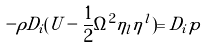Convert formula to latex. <formula><loc_0><loc_0><loc_500><loc_500>- \rho D _ { i } ( U - \frac { 1 } { 2 } \Omega ^ { 2 } \eta _ { l } \eta ^ { l } ) = D _ { i } p</formula> 